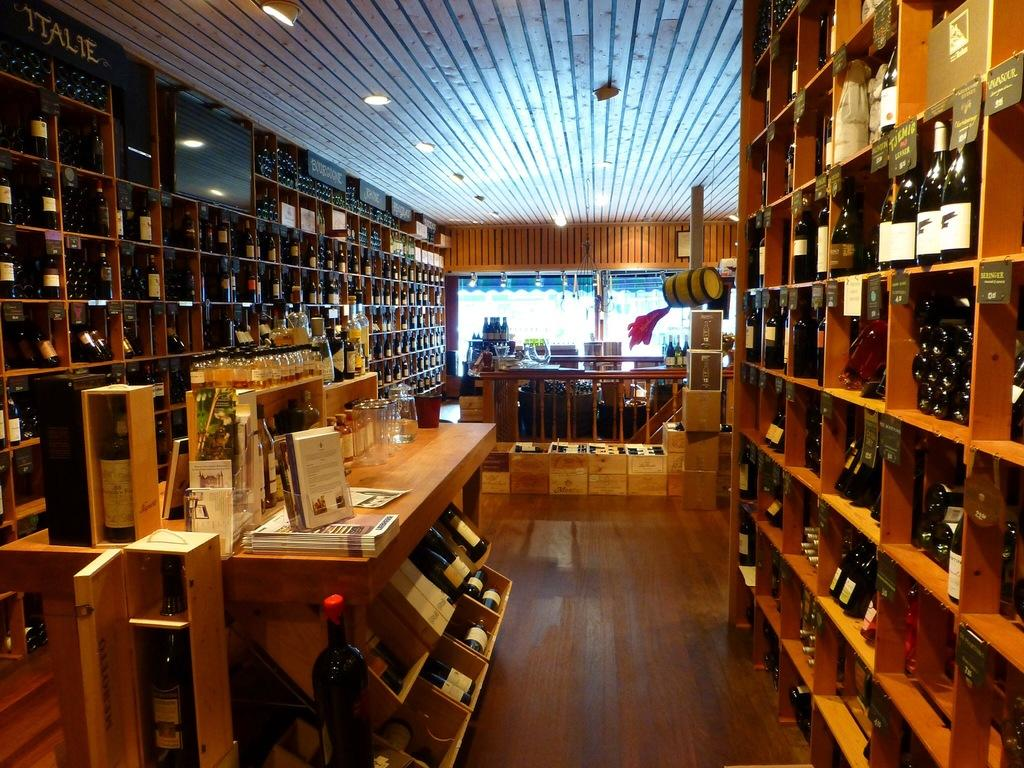What objects are present in the image? There are different types of bottles in the image. Where are the bottles located? The bottles are on shelves. What type of tin can be seen in the image? There is no tin present in the image; it features different types of bottles on shelves. What kind of loaf is visible in the image? There is no loaf present in the image. 